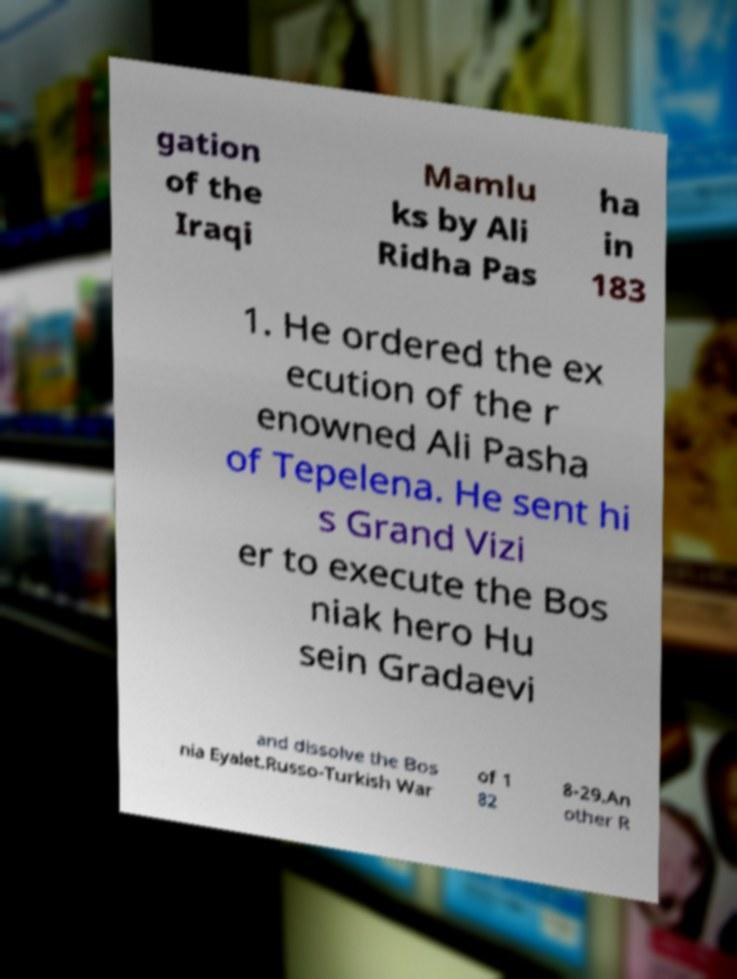I need the written content from this picture converted into text. Can you do that? gation of the Iraqi Mamlu ks by Ali Ridha Pas ha in 183 1. He ordered the ex ecution of the r enowned Ali Pasha of Tepelena. He sent hi s Grand Vizi er to execute the Bos niak hero Hu sein Gradaevi and dissolve the Bos nia Eyalet.Russo-Turkish War of 1 82 8-29.An other R 